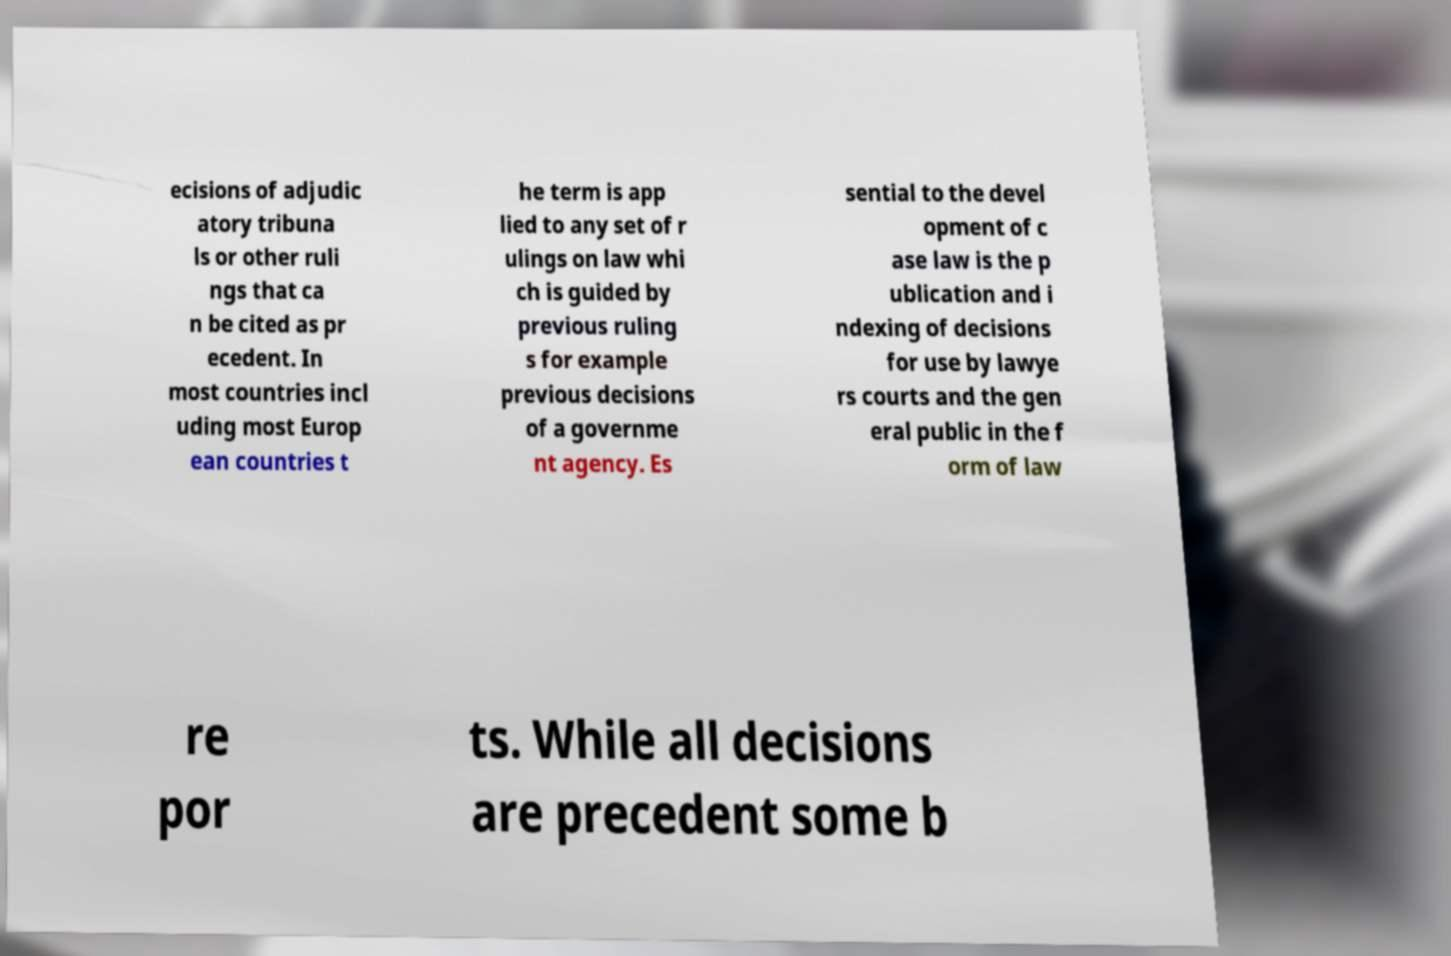What messages or text are displayed in this image? I need them in a readable, typed format. ecisions of adjudic atory tribuna ls or other ruli ngs that ca n be cited as pr ecedent. In most countries incl uding most Europ ean countries t he term is app lied to any set of r ulings on law whi ch is guided by previous ruling s for example previous decisions of a governme nt agency. Es sential to the devel opment of c ase law is the p ublication and i ndexing of decisions for use by lawye rs courts and the gen eral public in the f orm of law re por ts. While all decisions are precedent some b 